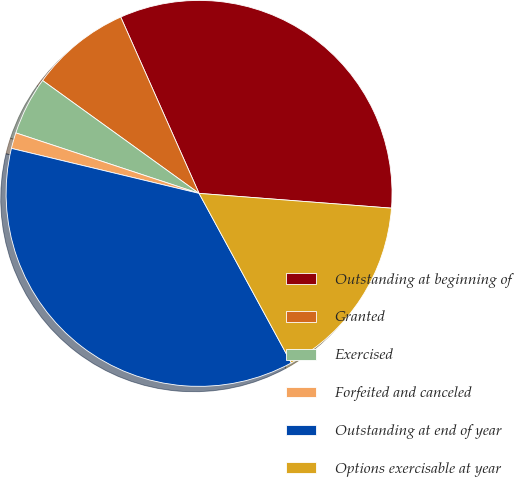Convert chart. <chart><loc_0><loc_0><loc_500><loc_500><pie_chart><fcel>Outstanding at beginning of<fcel>Granted<fcel>Exercised<fcel>Forfeited and canceled<fcel>Outstanding at end of year<fcel>Options exercisable at year<nl><fcel>32.87%<fcel>8.4%<fcel>4.87%<fcel>1.33%<fcel>36.67%<fcel>15.85%<nl></chart> 